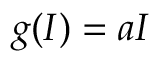<formula> <loc_0><loc_0><loc_500><loc_500>g ( I ) = a I</formula> 